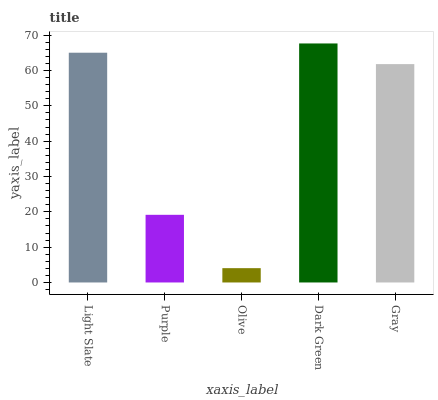Is Olive the minimum?
Answer yes or no. Yes. Is Dark Green the maximum?
Answer yes or no. Yes. Is Purple the minimum?
Answer yes or no. No. Is Purple the maximum?
Answer yes or no. No. Is Light Slate greater than Purple?
Answer yes or no. Yes. Is Purple less than Light Slate?
Answer yes or no. Yes. Is Purple greater than Light Slate?
Answer yes or no. No. Is Light Slate less than Purple?
Answer yes or no. No. Is Gray the high median?
Answer yes or no. Yes. Is Gray the low median?
Answer yes or no. Yes. Is Light Slate the high median?
Answer yes or no. No. Is Light Slate the low median?
Answer yes or no. No. 